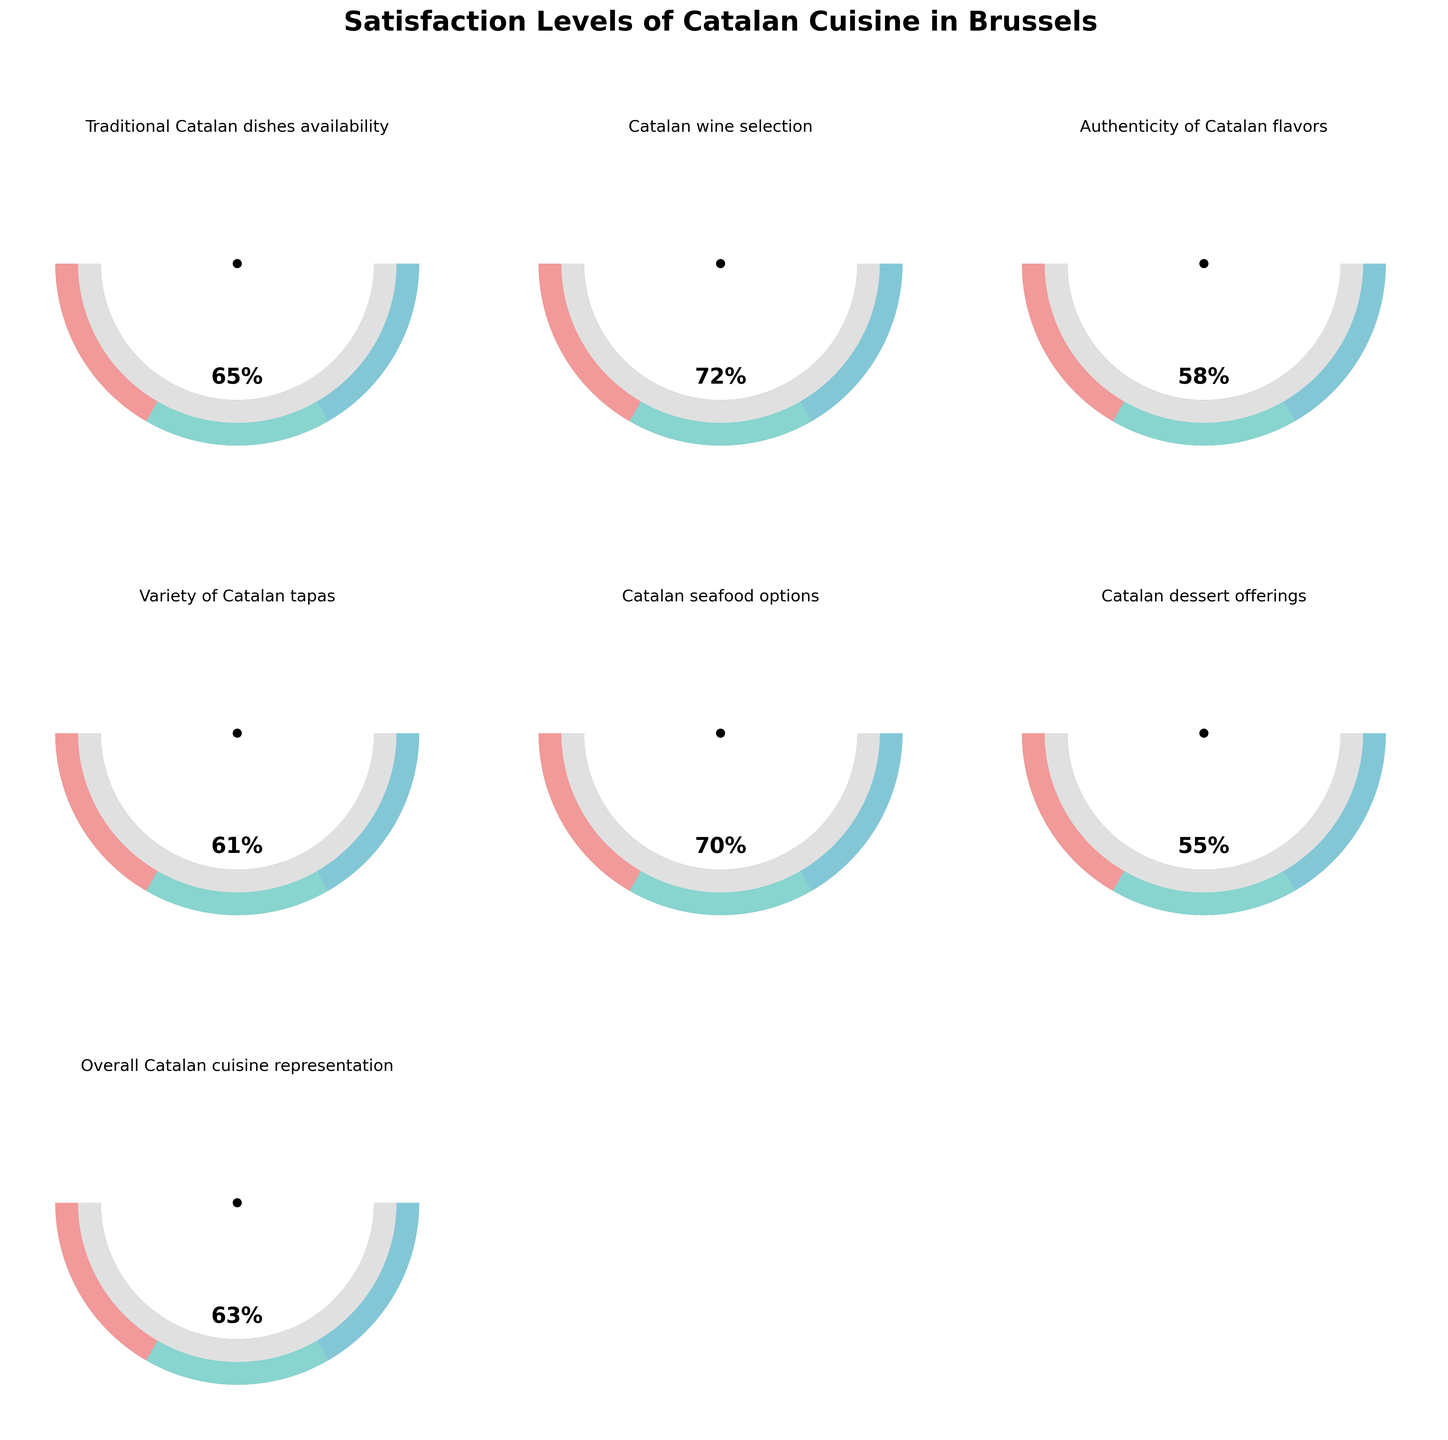Which parameter has the highest satisfaction level? To determine the highest satisfaction level, look at each gauge and identify the one with the highest percentage. "Catalan wine selection" has a value of 72%, which is the highest among all parameters.
Answer: Catalan wine selection What is the title of the figure? The title of the figure is usually placed at the top and provides an overview of what the chart is about. The title here reads "Satisfaction Levels of Catalan Cuisine in Brussels."
Answer: Satisfaction Levels of Catalan Cuisine in Brussels Which parameter has the lowest satisfaction level? To find the lowest satisfaction level, scan through all the gauges and identify the parameter with the smallest percentage. "Catalan dessert offerings" have a value of 55%, which is the lowest among all parameters.
Answer: Catalan dessert offerings What's the average satisfaction level across all parameters? Sum all satisfaction levels and divide by the number of parameters. (65 + 72 + 58 + 61 + 70 + 55 + 63) = 444. The number of parameters is 7. So, the average is 444 / 7 = 63.43%.
Answer: 63.43% How many parameters have satisfaction levels greater than 60%? Check each gauge to count how many have values greater than 60%. Parameters greater than 60% are Traditional Catalan dishes availability (65%), Catalan wine selection (72%), Variety of Catalan tapas (61%), Catalan seafood options (70%), and Overall Catalan cuisine representation (63%). This results in 5 parameters.
Answer: 5 What is the combined satisfaction level of "Traditional Catalan dishes availability" and "Variety of Catalan tapas"? Add the satisfaction levels of "Traditional Catalan dishes availability" (65%) and "Variety of Catalan tapas" (61%). The combined level is 65 + 61 = 126.
Answer: 126% What is the difference in satisfaction levels between "Overall Catalan cuisine representation" and "Authenticity of Catalan flavors"? Subtract the satisfaction level of "Authenticity of Catalan flavors" (58%) from "Overall Catalan cuisine representation" (63%). The difference is 63 - 58 = 5.
Answer: 5 Which parameters have satisfaction levels between 60% and 70% inclusive? Identify the gauges where satisfaction levels are between 60% and 70%. Parameters meeting this criterion are Traditional Catalan dishes availability (65%), Variety of Catalan tapas (61%), Catalan seafood options (70%), and Overall Catalan cuisine representation (63%).
Answer: Traditional Catalan dishes availability, Variety of Catalan tapas, Catalan seafood options, Overall Catalan cuisine representation 